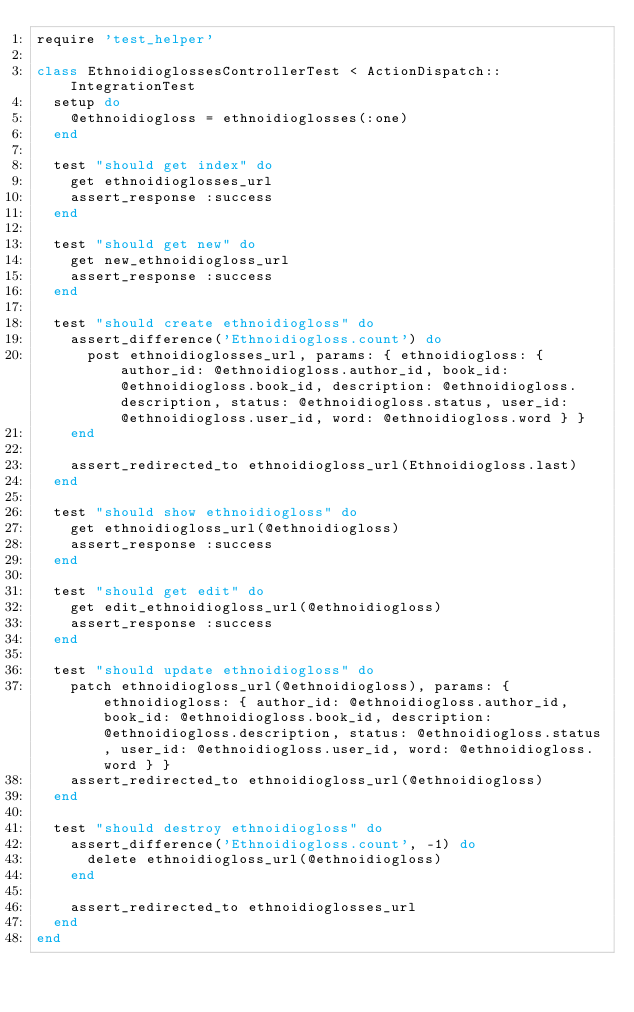Convert code to text. <code><loc_0><loc_0><loc_500><loc_500><_Ruby_>require 'test_helper'

class EthnoidioglossesControllerTest < ActionDispatch::IntegrationTest
  setup do
    @ethnoidiogloss = ethnoidioglosses(:one)
  end

  test "should get index" do
    get ethnoidioglosses_url
    assert_response :success
  end

  test "should get new" do
    get new_ethnoidiogloss_url
    assert_response :success
  end

  test "should create ethnoidiogloss" do
    assert_difference('Ethnoidiogloss.count') do
      post ethnoidioglosses_url, params: { ethnoidiogloss: { author_id: @ethnoidiogloss.author_id, book_id: @ethnoidiogloss.book_id, description: @ethnoidiogloss.description, status: @ethnoidiogloss.status, user_id: @ethnoidiogloss.user_id, word: @ethnoidiogloss.word } }
    end

    assert_redirected_to ethnoidiogloss_url(Ethnoidiogloss.last)
  end

  test "should show ethnoidiogloss" do
    get ethnoidiogloss_url(@ethnoidiogloss)
    assert_response :success
  end

  test "should get edit" do
    get edit_ethnoidiogloss_url(@ethnoidiogloss)
    assert_response :success
  end

  test "should update ethnoidiogloss" do
    patch ethnoidiogloss_url(@ethnoidiogloss), params: { ethnoidiogloss: { author_id: @ethnoidiogloss.author_id, book_id: @ethnoidiogloss.book_id, description: @ethnoidiogloss.description, status: @ethnoidiogloss.status, user_id: @ethnoidiogloss.user_id, word: @ethnoidiogloss.word } }
    assert_redirected_to ethnoidiogloss_url(@ethnoidiogloss)
  end

  test "should destroy ethnoidiogloss" do
    assert_difference('Ethnoidiogloss.count', -1) do
      delete ethnoidiogloss_url(@ethnoidiogloss)
    end

    assert_redirected_to ethnoidioglosses_url
  end
end
</code> 